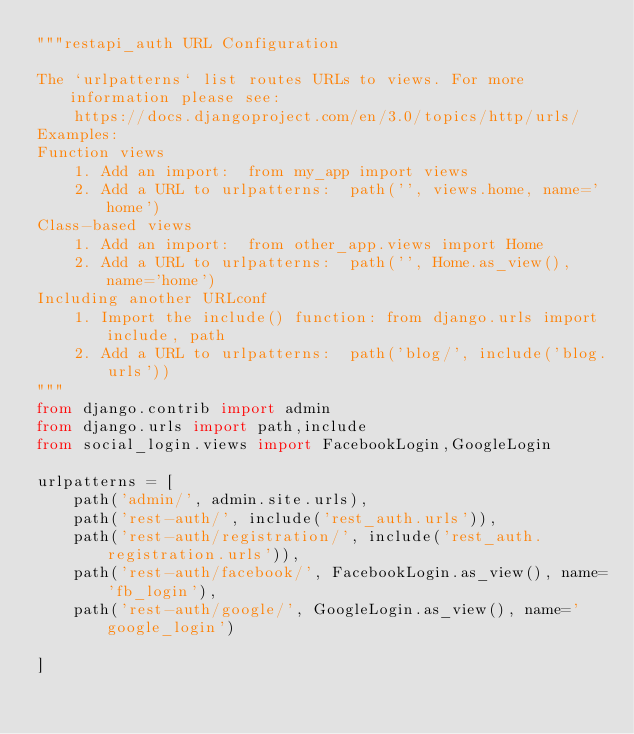<code> <loc_0><loc_0><loc_500><loc_500><_Python_>"""restapi_auth URL Configuration

The `urlpatterns` list routes URLs to views. For more information please see:
    https://docs.djangoproject.com/en/3.0/topics/http/urls/
Examples:
Function views
    1. Add an import:  from my_app import views
    2. Add a URL to urlpatterns:  path('', views.home, name='home')
Class-based views
    1. Add an import:  from other_app.views import Home
    2. Add a URL to urlpatterns:  path('', Home.as_view(), name='home')
Including another URLconf
    1. Import the include() function: from django.urls import include, path
    2. Add a URL to urlpatterns:  path('blog/', include('blog.urls'))
"""
from django.contrib import admin
from django.urls import path,include
from social_login.views import FacebookLogin,GoogleLogin

urlpatterns = [
    path('admin/', admin.site.urls),
    path('rest-auth/', include('rest_auth.urls')),
    path('rest-auth/registration/', include('rest_auth.registration.urls')),
    path('rest-auth/facebook/', FacebookLogin.as_view(), name='fb_login'),
    path('rest-auth/google/', GoogleLogin.as_view(), name='google_login')

]
</code> 